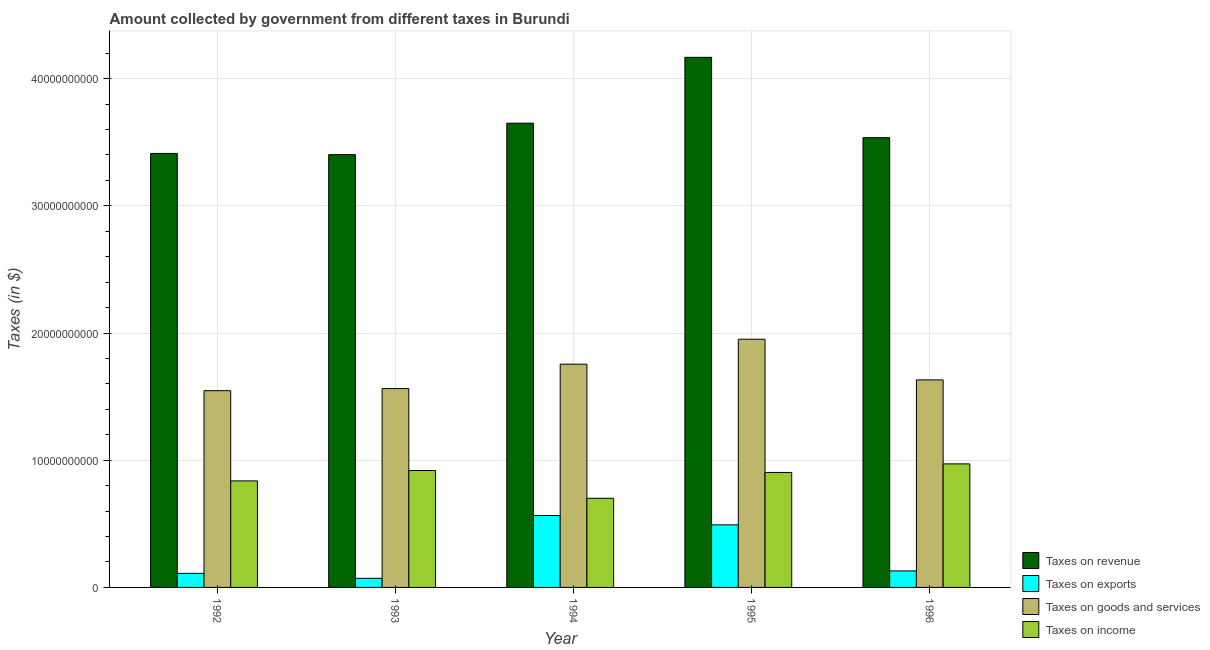How many bars are there on the 1st tick from the left?
Offer a terse response. 4. How many bars are there on the 1st tick from the right?
Your response must be concise. 4. In how many cases, is the number of bars for a given year not equal to the number of legend labels?
Offer a terse response. 0. What is the amount collected as tax on revenue in 1993?
Your answer should be compact. 3.40e+1. Across all years, what is the maximum amount collected as tax on exports?
Offer a terse response. 5.65e+09. Across all years, what is the minimum amount collected as tax on revenue?
Ensure brevity in your answer.  3.40e+1. What is the total amount collected as tax on income in the graph?
Provide a succinct answer. 4.33e+1. What is the difference between the amount collected as tax on income in 1993 and that in 1994?
Provide a short and direct response. 2.18e+09. What is the difference between the amount collected as tax on revenue in 1992 and the amount collected as tax on income in 1996?
Provide a succinct answer. -1.24e+09. What is the average amount collected as tax on income per year?
Offer a very short reply. 8.67e+09. In the year 1992, what is the difference between the amount collected as tax on goods and amount collected as tax on revenue?
Give a very brief answer. 0. In how many years, is the amount collected as tax on revenue greater than 32000000000 $?
Ensure brevity in your answer.  5. What is the ratio of the amount collected as tax on income in 1992 to that in 1993?
Offer a very short reply. 0.91. What is the difference between the highest and the second highest amount collected as tax on revenue?
Your answer should be very brief. 5.18e+09. What is the difference between the highest and the lowest amount collected as tax on income?
Offer a terse response. 2.70e+09. In how many years, is the amount collected as tax on goods greater than the average amount collected as tax on goods taken over all years?
Your answer should be compact. 2. Is it the case that in every year, the sum of the amount collected as tax on exports and amount collected as tax on goods is greater than the sum of amount collected as tax on revenue and amount collected as tax on income?
Give a very brief answer. No. What does the 4th bar from the left in 1992 represents?
Provide a short and direct response. Taxes on income. What does the 2nd bar from the right in 1993 represents?
Ensure brevity in your answer.  Taxes on goods and services. Is it the case that in every year, the sum of the amount collected as tax on revenue and amount collected as tax on exports is greater than the amount collected as tax on goods?
Your answer should be compact. Yes. How many bars are there?
Provide a short and direct response. 20. How many years are there in the graph?
Your answer should be compact. 5. What is the difference between two consecutive major ticks on the Y-axis?
Provide a short and direct response. 1.00e+1. Are the values on the major ticks of Y-axis written in scientific E-notation?
Provide a succinct answer. No. Does the graph contain any zero values?
Offer a very short reply. No. How many legend labels are there?
Offer a very short reply. 4. How are the legend labels stacked?
Provide a succinct answer. Vertical. What is the title of the graph?
Your answer should be compact. Amount collected by government from different taxes in Burundi. What is the label or title of the X-axis?
Make the answer very short. Year. What is the label or title of the Y-axis?
Offer a terse response. Taxes (in $). What is the Taxes (in $) of Taxes on revenue in 1992?
Give a very brief answer. 3.41e+1. What is the Taxes (in $) of Taxes on exports in 1992?
Your response must be concise. 1.11e+09. What is the Taxes (in $) in Taxes on goods and services in 1992?
Offer a very short reply. 1.55e+1. What is the Taxes (in $) in Taxes on income in 1992?
Offer a very short reply. 8.37e+09. What is the Taxes (in $) in Taxes on revenue in 1993?
Offer a terse response. 3.40e+1. What is the Taxes (in $) of Taxes on exports in 1993?
Offer a terse response. 7.16e+08. What is the Taxes (in $) of Taxes on goods and services in 1993?
Ensure brevity in your answer.  1.56e+1. What is the Taxes (in $) in Taxes on income in 1993?
Provide a short and direct response. 9.19e+09. What is the Taxes (in $) of Taxes on revenue in 1994?
Keep it short and to the point. 3.65e+1. What is the Taxes (in $) in Taxes on exports in 1994?
Your response must be concise. 5.65e+09. What is the Taxes (in $) of Taxes on goods and services in 1994?
Offer a very short reply. 1.76e+1. What is the Taxes (in $) in Taxes on income in 1994?
Your answer should be compact. 7.01e+09. What is the Taxes (in $) in Taxes on revenue in 1995?
Offer a very short reply. 4.17e+1. What is the Taxes (in $) in Taxes on exports in 1995?
Ensure brevity in your answer.  4.92e+09. What is the Taxes (in $) of Taxes on goods and services in 1995?
Your answer should be compact. 1.95e+1. What is the Taxes (in $) in Taxes on income in 1995?
Keep it short and to the point. 9.04e+09. What is the Taxes (in $) of Taxes on revenue in 1996?
Provide a succinct answer. 3.54e+1. What is the Taxes (in $) of Taxes on exports in 1996?
Make the answer very short. 1.30e+09. What is the Taxes (in $) of Taxes on goods and services in 1996?
Ensure brevity in your answer.  1.63e+1. What is the Taxes (in $) in Taxes on income in 1996?
Make the answer very short. 9.71e+09. Across all years, what is the maximum Taxes (in $) of Taxes on revenue?
Your answer should be compact. 4.17e+1. Across all years, what is the maximum Taxes (in $) in Taxes on exports?
Your answer should be very brief. 5.65e+09. Across all years, what is the maximum Taxes (in $) of Taxes on goods and services?
Your response must be concise. 1.95e+1. Across all years, what is the maximum Taxes (in $) in Taxes on income?
Make the answer very short. 9.71e+09. Across all years, what is the minimum Taxes (in $) of Taxes on revenue?
Keep it short and to the point. 3.40e+1. Across all years, what is the minimum Taxes (in $) of Taxes on exports?
Provide a short and direct response. 7.16e+08. Across all years, what is the minimum Taxes (in $) of Taxes on goods and services?
Your response must be concise. 1.55e+1. Across all years, what is the minimum Taxes (in $) in Taxes on income?
Provide a short and direct response. 7.01e+09. What is the total Taxes (in $) in Taxes on revenue in the graph?
Provide a short and direct response. 1.82e+11. What is the total Taxes (in $) in Taxes on exports in the graph?
Provide a short and direct response. 1.37e+1. What is the total Taxes (in $) of Taxes on goods and services in the graph?
Make the answer very short. 8.45e+1. What is the total Taxes (in $) of Taxes on income in the graph?
Your response must be concise. 4.33e+1. What is the difference between the Taxes (in $) of Taxes on revenue in 1992 and that in 1993?
Your answer should be compact. 9.40e+07. What is the difference between the Taxes (in $) of Taxes on exports in 1992 and that in 1993?
Your response must be concise. 3.90e+08. What is the difference between the Taxes (in $) of Taxes on goods and services in 1992 and that in 1993?
Your response must be concise. -1.65e+08. What is the difference between the Taxes (in $) of Taxes on income in 1992 and that in 1993?
Provide a short and direct response. -8.18e+08. What is the difference between the Taxes (in $) of Taxes on revenue in 1992 and that in 1994?
Give a very brief answer. -2.38e+09. What is the difference between the Taxes (in $) of Taxes on exports in 1992 and that in 1994?
Make the answer very short. -4.55e+09. What is the difference between the Taxes (in $) of Taxes on goods and services in 1992 and that in 1994?
Give a very brief answer. -2.08e+09. What is the difference between the Taxes (in $) in Taxes on income in 1992 and that in 1994?
Provide a succinct answer. 1.36e+09. What is the difference between the Taxes (in $) of Taxes on revenue in 1992 and that in 1995?
Make the answer very short. -7.56e+09. What is the difference between the Taxes (in $) of Taxes on exports in 1992 and that in 1995?
Make the answer very short. -3.81e+09. What is the difference between the Taxes (in $) in Taxes on goods and services in 1992 and that in 1995?
Your response must be concise. -4.04e+09. What is the difference between the Taxes (in $) in Taxes on income in 1992 and that in 1995?
Your response must be concise. -6.65e+08. What is the difference between the Taxes (in $) in Taxes on revenue in 1992 and that in 1996?
Offer a terse response. -1.24e+09. What is the difference between the Taxes (in $) in Taxes on exports in 1992 and that in 1996?
Your answer should be compact. -1.92e+08. What is the difference between the Taxes (in $) of Taxes on goods and services in 1992 and that in 1996?
Ensure brevity in your answer.  -8.49e+08. What is the difference between the Taxes (in $) in Taxes on income in 1992 and that in 1996?
Give a very brief answer. -1.34e+09. What is the difference between the Taxes (in $) in Taxes on revenue in 1993 and that in 1994?
Keep it short and to the point. -2.48e+09. What is the difference between the Taxes (in $) of Taxes on exports in 1993 and that in 1994?
Offer a very short reply. -4.94e+09. What is the difference between the Taxes (in $) of Taxes on goods and services in 1993 and that in 1994?
Ensure brevity in your answer.  -1.92e+09. What is the difference between the Taxes (in $) of Taxes on income in 1993 and that in 1994?
Offer a very short reply. 2.18e+09. What is the difference between the Taxes (in $) of Taxes on revenue in 1993 and that in 1995?
Provide a short and direct response. -7.65e+09. What is the difference between the Taxes (in $) in Taxes on exports in 1993 and that in 1995?
Offer a terse response. -4.20e+09. What is the difference between the Taxes (in $) of Taxes on goods and services in 1993 and that in 1995?
Your answer should be very brief. -3.88e+09. What is the difference between the Taxes (in $) in Taxes on income in 1993 and that in 1995?
Your answer should be very brief. 1.53e+08. What is the difference between the Taxes (in $) of Taxes on revenue in 1993 and that in 1996?
Ensure brevity in your answer.  -1.34e+09. What is the difference between the Taxes (in $) of Taxes on exports in 1993 and that in 1996?
Your answer should be very brief. -5.82e+08. What is the difference between the Taxes (in $) in Taxes on goods and services in 1993 and that in 1996?
Provide a succinct answer. -6.84e+08. What is the difference between the Taxes (in $) of Taxes on income in 1993 and that in 1996?
Your response must be concise. -5.20e+08. What is the difference between the Taxes (in $) in Taxes on revenue in 1994 and that in 1995?
Your answer should be compact. -5.18e+09. What is the difference between the Taxes (in $) in Taxes on exports in 1994 and that in 1995?
Your answer should be compact. 7.33e+08. What is the difference between the Taxes (in $) in Taxes on goods and services in 1994 and that in 1995?
Give a very brief answer. -1.96e+09. What is the difference between the Taxes (in $) of Taxes on income in 1994 and that in 1995?
Provide a succinct answer. -2.03e+09. What is the difference between the Taxes (in $) in Taxes on revenue in 1994 and that in 1996?
Keep it short and to the point. 1.14e+09. What is the difference between the Taxes (in $) of Taxes on exports in 1994 and that in 1996?
Offer a terse response. 4.35e+09. What is the difference between the Taxes (in $) of Taxes on goods and services in 1994 and that in 1996?
Your response must be concise. 1.23e+09. What is the difference between the Taxes (in $) in Taxes on income in 1994 and that in 1996?
Provide a succinct answer. -2.70e+09. What is the difference between the Taxes (in $) in Taxes on revenue in 1995 and that in 1996?
Offer a very short reply. 6.32e+09. What is the difference between the Taxes (in $) in Taxes on exports in 1995 and that in 1996?
Your response must be concise. 3.62e+09. What is the difference between the Taxes (in $) in Taxes on goods and services in 1995 and that in 1996?
Provide a succinct answer. 3.20e+09. What is the difference between the Taxes (in $) in Taxes on income in 1995 and that in 1996?
Make the answer very short. -6.73e+08. What is the difference between the Taxes (in $) of Taxes on revenue in 1992 and the Taxes (in $) of Taxes on exports in 1993?
Make the answer very short. 3.34e+1. What is the difference between the Taxes (in $) in Taxes on revenue in 1992 and the Taxes (in $) in Taxes on goods and services in 1993?
Your answer should be compact. 1.85e+1. What is the difference between the Taxes (in $) in Taxes on revenue in 1992 and the Taxes (in $) in Taxes on income in 1993?
Provide a short and direct response. 2.49e+1. What is the difference between the Taxes (in $) in Taxes on exports in 1992 and the Taxes (in $) in Taxes on goods and services in 1993?
Make the answer very short. -1.45e+1. What is the difference between the Taxes (in $) in Taxes on exports in 1992 and the Taxes (in $) in Taxes on income in 1993?
Your answer should be very brief. -8.09e+09. What is the difference between the Taxes (in $) in Taxes on goods and services in 1992 and the Taxes (in $) in Taxes on income in 1993?
Make the answer very short. 6.28e+09. What is the difference between the Taxes (in $) in Taxes on revenue in 1992 and the Taxes (in $) in Taxes on exports in 1994?
Offer a very short reply. 2.85e+1. What is the difference between the Taxes (in $) in Taxes on revenue in 1992 and the Taxes (in $) in Taxes on goods and services in 1994?
Your response must be concise. 1.66e+1. What is the difference between the Taxes (in $) of Taxes on revenue in 1992 and the Taxes (in $) of Taxes on income in 1994?
Make the answer very short. 2.71e+1. What is the difference between the Taxes (in $) of Taxes on exports in 1992 and the Taxes (in $) of Taxes on goods and services in 1994?
Make the answer very short. -1.64e+1. What is the difference between the Taxes (in $) in Taxes on exports in 1992 and the Taxes (in $) in Taxes on income in 1994?
Provide a succinct answer. -5.90e+09. What is the difference between the Taxes (in $) in Taxes on goods and services in 1992 and the Taxes (in $) in Taxes on income in 1994?
Offer a terse response. 8.46e+09. What is the difference between the Taxes (in $) of Taxes on revenue in 1992 and the Taxes (in $) of Taxes on exports in 1995?
Offer a very short reply. 2.92e+1. What is the difference between the Taxes (in $) of Taxes on revenue in 1992 and the Taxes (in $) of Taxes on goods and services in 1995?
Make the answer very short. 1.46e+1. What is the difference between the Taxes (in $) in Taxes on revenue in 1992 and the Taxes (in $) in Taxes on income in 1995?
Your answer should be compact. 2.51e+1. What is the difference between the Taxes (in $) in Taxes on exports in 1992 and the Taxes (in $) in Taxes on goods and services in 1995?
Your response must be concise. -1.84e+1. What is the difference between the Taxes (in $) in Taxes on exports in 1992 and the Taxes (in $) in Taxes on income in 1995?
Make the answer very short. -7.93e+09. What is the difference between the Taxes (in $) in Taxes on goods and services in 1992 and the Taxes (in $) in Taxes on income in 1995?
Keep it short and to the point. 6.43e+09. What is the difference between the Taxes (in $) of Taxes on revenue in 1992 and the Taxes (in $) of Taxes on exports in 1996?
Provide a short and direct response. 3.28e+1. What is the difference between the Taxes (in $) of Taxes on revenue in 1992 and the Taxes (in $) of Taxes on goods and services in 1996?
Your answer should be compact. 1.78e+1. What is the difference between the Taxes (in $) in Taxes on revenue in 1992 and the Taxes (in $) in Taxes on income in 1996?
Provide a succinct answer. 2.44e+1. What is the difference between the Taxes (in $) of Taxes on exports in 1992 and the Taxes (in $) of Taxes on goods and services in 1996?
Offer a very short reply. -1.52e+1. What is the difference between the Taxes (in $) of Taxes on exports in 1992 and the Taxes (in $) of Taxes on income in 1996?
Keep it short and to the point. -8.61e+09. What is the difference between the Taxes (in $) of Taxes on goods and services in 1992 and the Taxes (in $) of Taxes on income in 1996?
Offer a terse response. 5.76e+09. What is the difference between the Taxes (in $) in Taxes on revenue in 1993 and the Taxes (in $) in Taxes on exports in 1994?
Provide a succinct answer. 2.84e+1. What is the difference between the Taxes (in $) of Taxes on revenue in 1993 and the Taxes (in $) of Taxes on goods and services in 1994?
Ensure brevity in your answer.  1.65e+1. What is the difference between the Taxes (in $) of Taxes on revenue in 1993 and the Taxes (in $) of Taxes on income in 1994?
Make the answer very short. 2.70e+1. What is the difference between the Taxes (in $) of Taxes on exports in 1993 and the Taxes (in $) of Taxes on goods and services in 1994?
Your response must be concise. -1.68e+1. What is the difference between the Taxes (in $) of Taxes on exports in 1993 and the Taxes (in $) of Taxes on income in 1994?
Give a very brief answer. -6.29e+09. What is the difference between the Taxes (in $) of Taxes on goods and services in 1993 and the Taxes (in $) of Taxes on income in 1994?
Make the answer very short. 8.62e+09. What is the difference between the Taxes (in $) in Taxes on revenue in 1993 and the Taxes (in $) in Taxes on exports in 1995?
Provide a short and direct response. 2.91e+1. What is the difference between the Taxes (in $) in Taxes on revenue in 1993 and the Taxes (in $) in Taxes on goods and services in 1995?
Make the answer very short. 1.45e+1. What is the difference between the Taxes (in $) of Taxes on revenue in 1993 and the Taxes (in $) of Taxes on income in 1995?
Ensure brevity in your answer.  2.50e+1. What is the difference between the Taxes (in $) in Taxes on exports in 1993 and the Taxes (in $) in Taxes on goods and services in 1995?
Ensure brevity in your answer.  -1.88e+1. What is the difference between the Taxes (in $) of Taxes on exports in 1993 and the Taxes (in $) of Taxes on income in 1995?
Offer a very short reply. -8.32e+09. What is the difference between the Taxes (in $) in Taxes on goods and services in 1993 and the Taxes (in $) in Taxes on income in 1995?
Keep it short and to the point. 6.59e+09. What is the difference between the Taxes (in $) in Taxes on revenue in 1993 and the Taxes (in $) in Taxes on exports in 1996?
Your response must be concise. 3.27e+1. What is the difference between the Taxes (in $) of Taxes on revenue in 1993 and the Taxes (in $) of Taxes on goods and services in 1996?
Ensure brevity in your answer.  1.77e+1. What is the difference between the Taxes (in $) of Taxes on revenue in 1993 and the Taxes (in $) of Taxes on income in 1996?
Provide a short and direct response. 2.43e+1. What is the difference between the Taxes (in $) in Taxes on exports in 1993 and the Taxes (in $) in Taxes on goods and services in 1996?
Provide a short and direct response. -1.56e+1. What is the difference between the Taxes (in $) of Taxes on exports in 1993 and the Taxes (in $) of Taxes on income in 1996?
Your answer should be compact. -9.00e+09. What is the difference between the Taxes (in $) in Taxes on goods and services in 1993 and the Taxes (in $) in Taxes on income in 1996?
Provide a short and direct response. 5.92e+09. What is the difference between the Taxes (in $) of Taxes on revenue in 1994 and the Taxes (in $) of Taxes on exports in 1995?
Your answer should be very brief. 3.16e+1. What is the difference between the Taxes (in $) in Taxes on revenue in 1994 and the Taxes (in $) in Taxes on goods and services in 1995?
Offer a terse response. 1.70e+1. What is the difference between the Taxes (in $) of Taxes on revenue in 1994 and the Taxes (in $) of Taxes on income in 1995?
Your response must be concise. 2.75e+1. What is the difference between the Taxes (in $) in Taxes on exports in 1994 and the Taxes (in $) in Taxes on goods and services in 1995?
Ensure brevity in your answer.  -1.39e+1. What is the difference between the Taxes (in $) in Taxes on exports in 1994 and the Taxes (in $) in Taxes on income in 1995?
Provide a succinct answer. -3.39e+09. What is the difference between the Taxes (in $) of Taxes on goods and services in 1994 and the Taxes (in $) of Taxes on income in 1995?
Offer a terse response. 8.51e+09. What is the difference between the Taxes (in $) of Taxes on revenue in 1994 and the Taxes (in $) of Taxes on exports in 1996?
Offer a very short reply. 3.52e+1. What is the difference between the Taxes (in $) of Taxes on revenue in 1994 and the Taxes (in $) of Taxes on goods and services in 1996?
Give a very brief answer. 2.02e+1. What is the difference between the Taxes (in $) of Taxes on revenue in 1994 and the Taxes (in $) of Taxes on income in 1996?
Offer a very short reply. 2.68e+1. What is the difference between the Taxes (in $) in Taxes on exports in 1994 and the Taxes (in $) in Taxes on goods and services in 1996?
Make the answer very short. -1.07e+1. What is the difference between the Taxes (in $) of Taxes on exports in 1994 and the Taxes (in $) of Taxes on income in 1996?
Offer a terse response. -4.06e+09. What is the difference between the Taxes (in $) in Taxes on goods and services in 1994 and the Taxes (in $) in Taxes on income in 1996?
Make the answer very short. 7.84e+09. What is the difference between the Taxes (in $) of Taxes on revenue in 1995 and the Taxes (in $) of Taxes on exports in 1996?
Provide a succinct answer. 4.04e+1. What is the difference between the Taxes (in $) in Taxes on revenue in 1995 and the Taxes (in $) in Taxes on goods and services in 1996?
Keep it short and to the point. 2.54e+1. What is the difference between the Taxes (in $) in Taxes on revenue in 1995 and the Taxes (in $) in Taxes on income in 1996?
Keep it short and to the point. 3.20e+1. What is the difference between the Taxes (in $) of Taxes on exports in 1995 and the Taxes (in $) of Taxes on goods and services in 1996?
Ensure brevity in your answer.  -1.14e+1. What is the difference between the Taxes (in $) in Taxes on exports in 1995 and the Taxes (in $) in Taxes on income in 1996?
Your answer should be very brief. -4.79e+09. What is the difference between the Taxes (in $) in Taxes on goods and services in 1995 and the Taxes (in $) in Taxes on income in 1996?
Your response must be concise. 9.80e+09. What is the average Taxes (in $) in Taxes on revenue per year?
Your answer should be very brief. 3.63e+1. What is the average Taxes (in $) in Taxes on exports per year?
Give a very brief answer. 2.74e+09. What is the average Taxes (in $) in Taxes on goods and services per year?
Make the answer very short. 1.69e+1. What is the average Taxes (in $) in Taxes on income per year?
Make the answer very short. 8.67e+09. In the year 1992, what is the difference between the Taxes (in $) in Taxes on revenue and Taxes (in $) in Taxes on exports?
Your response must be concise. 3.30e+1. In the year 1992, what is the difference between the Taxes (in $) of Taxes on revenue and Taxes (in $) of Taxes on goods and services?
Offer a terse response. 1.86e+1. In the year 1992, what is the difference between the Taxes (in $) of Taxes on revenue and Taxes (in $) of Taxes on income?
Give a very brief answer. 2.57e+1. In the year 1992, what is the difference between the Taxes (in $) in Taxes on exports and Taxes (in $) in Taxes on goods and services?
Offer a terse response. -1.44e+1. In the year 1992, what is the difference between the Taxes (in $) of Taxes on exports and Taxes (in $) of Taxes on income?
Give a very brief answer. -7.27e+09. In the year 1992, what is the difference between the Taxes (in $) of Taxes on goods and services and Taxes (in $) of Taxes on income?
Ensure brevity in your answer.  7.09e+09. In the year 1993, what is the difference between the Taxes (in $) of Taxes on revenue and Taxes (in $) of Taxes on exports?
Offer a very short reply. 3.33e+1. In the year 1993, what is the difference between the Taxes (in $) of Taxes on revenue and Taxes (in $) of Taxes on goods and services?
Provide a succinct answer. 1.84e+1. In the year 1993, what is the difference between the Taxes (in $) of Taxes on revenue and Taxes (in $) of Taxes on income?
Offer a very short reply. 2.48e+1. In the year 1993, what is the difference between the Taxes (in $) of Taxes on exports and Taxes (in $) of Taxes on goods and services?
Provide a short and direct response. -1.49e+1. In the year 1993, what is the difference between the Taxes (in $) of Taxes on exports and Taxes (in $) of Taxes on income?
Make the answer very short. -8.48e+09. In the year 1993, what is the difference between the Taxes (in $) of Taxes on goods and services and Taxes (in $) of Taxes on income?
Provide a short and direct response. 6.44e+09. In the year 1994, what is the difference between the Taxes (in $) of Taxes on revenue and Taxes (in $) of Taxes on exports?
Ensure brevity in your answer.  3.08e+1. In the year 1994, what is the difference between the Taxes (in $) of Taxes on revenue and Taxes (in $) of Taxes on goods and services?
Make the answer very short. 1.89e+1. In the year 1994, what is the difference between the Taxes (in $) of Taxes on revenue and Taxes (in $) of Taxes on income?
Your answer should be very brief. 2.95e+1. In the year 1994, what is the difference between the Taxes (in $) in Taxes on exports and Taxes (in $) in Taxes on goods and services?
Offer a very short reply. -1.19e+1. In the year 1994, what is the difference between the Taxes (in $) in Taxes on exports and Taxes (in $) in Taxes on income?
Your answer should be compact. -1.36e+09. In the year 1994, what is the difference between the Taxes (in $) in Taxes on goods and services and Taxes (in $) in Taxes on income?
Your response must be concise. 1.05e+1. In the year 1995, what is the difference between the Taxes (in $) in Taxes on revenue and Taxes (in $) in Taxes on exports?
Your answer should be very brief. 3.68e+1. In the year 1995, what is the difference between the Taxes (in $) in Taxes on revenue and Taxes (in $) in Taxes on goods and services?
Provide a succinct answer. 2.22e+1. In the year 1995, what is the difference between the Taxes (in $) in Taxes on revenue and Taxes (in $) in Taxes on income?
Offer a very short reply. 3.26e+1. In the year 1995, what is the difference between the Taxes (in $) of Taxes on exports and Taxes (in $) of Taxes on goods and services?
Your answer should be compact. -1.46e+1. In the year 1995, what is the difference between the Taxes (in $) in Taxes on exports and Taxes (in $) in Taxes on income?
Provide a succinct answer. -4.12e+09. In the year 1995, what is the difference between the Taxes (in $) of Taxes on goods and services and Taxes (in $) of Taxes on income?
Give a very brief answer. 1.05e+1. In the year 1996, what is the difference between the Taxes (in $) in Taxes on revenue and Taxes (in $) in Taxes on exports?
Your response must be concise. 3.41e+1. In the year 1996, what is the difference between the Taxes (in $) in Taxes on revenue and Taxes (in $) in Taxes on goods and services?
Offer a terse response. 1.90e+1. In the year 1996, what is the difference between the Taxes (in $) of Taxes on revenue and Taxes (in $) of Taxes on income?
Offer a very short reply. 2.56e+1. In the year 1996, what is the difference between the Taxes (in $) of Taxes on exports and Taxes (in $) of Taxes on goods and services?
Ensure brevity in your answer.  -1.50e+1. In the year 1996, what is the difference between the Taxes (in $) in Taxes on exports and Taxes (in $) in Taxes on income?
Your response must be concise. -8.41e+09. In the year 1996, what is the difference between the Taxes (in $) in Taxes on goods and services and Taxes (in $) in Taxes on income?
Your answer should be compact. 6.60e+09. What is the ratio of the Taxes (in $) of Taxes on revenue in 1992 to that in 1993?
Give a very brief answer. 1. What is the ratio of the Taxes (in $) in Taxes on exports in 1992 to that in 1993?
Ensure brevity in your answer.  1.54. What is the ratio of the Taxes (in $) in Taxes on income in 1992 to that in 1993?
Make the answer very short. 0.91. What is the ratio of the Taxes (in $) of Taxes on revenue in 1992 to that in 1994?
Your answer should be compact. 0.93. What is the ratio of the Taxes (in $) in Taxes on exports in 1992 to that in 1994?
Make the answer very short. 0.2. What is the ratio of the Taxes (in $) in Taxes on goods and services in 1992 to that in 1994?
Give a very brief answer. 0.88. What is the ratio of the Taxes (in $) of Taxes on income in 1992 to that in 1994?
Your response must be concise. 1.19. What is the ratio of the Taxes (in $) of Taxes on revenue in 1992 to that in 1995?
Keep it short and to the point. 0.82. What is the ratio of the Taxes (in $) in Taxes on exports in 1992 to that in 1995?
Provide a short and direct response. 0.22. What is the ratio of the Taxes (in $) in Taxes on goods and services in 1992 to that in 1995?
Offer a terse response. 0.79. What is the ratio of the Taxes (in $) of Taxes on income in 1992 to that in 1995?
Give a very brief answer. 0.93. What is the ratio of the Taxes (in $) in Taxes on revenue in 1992 to that in 1996?
Give a very brief answer. 0.96. What is the ratio of the Taxes (in $) in Taxes on exports in 1992 to that in 1996?
Provide a short and direct response. 0.85. What is the ratio of the Taxes (in $) of Taxes on goods and services in 1992 to that in 1996?
Offer a very short reply. 0.95. What is the ratio of the Taxes (in $) of Taxes on income in 1992 to that in 1996?
Your response must be concise. 0.86. What is the ratio of the Taxes (in $) in Taxes on revenue in 1993 to that in 1994?
Keep it short and to the point. 0.93. What is the ratio of the Taxes (in $) of Taxes on exports in 1993 to that in 1994?
Provide a succinct answer. 0.13. What is the ratio of the Taxes (in $) of Taxes on goods and services in 1993 to that in 1994?
Provide a short and direct response. 0.89. What is the ratio of the Taxes (in $) of Taxes on income in 1993 to that in 1994?
Offer a very short reply. 1.31. What is the ratio of the Taxes (in $) of Taxes on revenue in 1993 to that in 1995?
Provide a short and direct response. 0.82. What is the ratio of the Taxes (in $) of Taxes on exports in 1993 to that in 1995?
Keep it short and to the point. 0.15. What is the ratio of the Taxes (in $) in Taxes on goods and services in 1993 to that in 1995?
Make the answer very short. 0.8. What is the ratio of the Taxes (in $) in Taxes on income in 1993 to that in 1995?
Offer a very short reply. 1.02. What is the ratio of the Taxes (in $) of Taxes on revenue in 1993 to that in 1996?
Your answer should be compact. 0.96. What is the ratio of the Taxes (in $) of Taxes on exports in 1993 to that in 1996?
Offer a very short reply. 0.55. What is the ratio of the Taxes (in $) in Taxes on goods and services in 1993 to that in 1996?
Give a very brief answer. 0.96. What is the ratio of the Taxes (in $) of Taxes on income in 1993 to that in 1996?
Keep it short and to the point. 0.95. What is the ratio of the Taxes (in $) in Taxes on revenue in 1994 to that in 1995?
Your answer should be very brief. 0.88. What is the ratio of the Taxes (in $) of Taxes on exports in 1994 to that in 1995?
Provide a succinct answer. 1.15. What is the ratio of the Taxes (in $) in Taxes on goods and services in 1994 to that in 1995?
Offer a terse response. 0.9. What is the ratio of the Taxes (in $) of Taxes on income in 1994 to that in 1995?
Offer a terse response. 0.78. What is the ratio of the Taxes (in $) in Taxes on revenue in 1994 to that in 1996?
Provide a succinct answer. 1.03. What is the ratio of the Taxes (in $) in Taxes on exports in 1994 to that in 1996?
Offer a terse response. 4.35. What is the ratio of the Taxes (in $) in Taxes on goods and services in 1994 to that in 1996?
Your answer should be compact. 1.08. What is the ratio of the Taxes (in $) in Taxes on income in 1994 to that in 1996?
Give a very brief answer. 0.72. What is the ratio of the Taxes (in $) of Taxes on revenue in 1995 to that in 1996?
Your answer should be very brief. 1.18. What is the ratio of the Taxes (in $) of Taxes on exports in 1995 to that in 1996?
Your answer should be very brief. 3.79. What is the ratio of the Taxes (in $) of Taxes on goods and services in 1995 to that in 1996?
Make the answer very short. 1.2. What is the ratio of the Taxes (in $) in Taxes on income in 1995 to that in 1996?
Give a very brief answer. 0.93. What is the difference between the highest and the second highest Taxes (in $) of Taxes on revenue?
Your answer should be compact. 5.18e+09. What is the difference between the highest and the second highest Taxes (in $) of Taxes on exports?
Make the answer very short. 7.33e+08. What is the difference between the highest and the second highest Taxes (in $) in Taxes on goods and services?
Give a very brief answer. 1.96e+09. What is the difference between the highest and the second highest Taxes (in $) of Taxes on income?
Give a very brief answer. 5.20e+08. What is the difference between the highest and the lowest Taxes (in $) of Taxes on revenue?
Offer a terse response. 7.65e+09. What is the difference between the highest and the lowest Taxes (in $) of Taxes on exports?
Offer a very short reply. 4.94e+09. What is the difference between the highest and the lowest Taxes (in $) in Taxes on goods and services?
Your response must be concise. 4.04e+09. What is the difference between the highest and the lowest Taxes (in $) of Taxes on income?
Make the answer very short. 2.70e+09. 